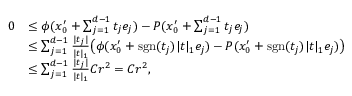Convert formula to latex. <formula><loc_0><loc_0><loc_500><loc_500>\begin{array} { r l } { 0 } & { \leq \phi ( x _ { 0 } ^ { \prime } + \sum _ { j = 1 } ^ { d - 1 } t _ { j } e _ { j } ) - P ( x _ { 0 } ^ { \prime } + \sum _ { j = 1 } ^ { d - 1 } t _ { j } e _ { j } ) } \\ & { \leq \sum _ { j = 1 } ^ { d - 1 } \frac { | t _ { j } | } { | t | _ { 1 } } \left ( \phi ( x _ { 0 } ^ { \prime } + s g n ( t _ { j } ) | t | _ { 1 } e _ { j } ) - P ( x _ { 0 } ^ { \prime } + s g n ( t _ { j } ) | t | _ { 1 } e _ { j } ) \right ) } \\ & { \leq \sum _ { j = 1 } ^ { d - 1 } \frac { | t _ { j } | } { | t | _ { 1 } } C r ^ { 2 } = C r ^ { 2 } , } \end{array}</formula> 